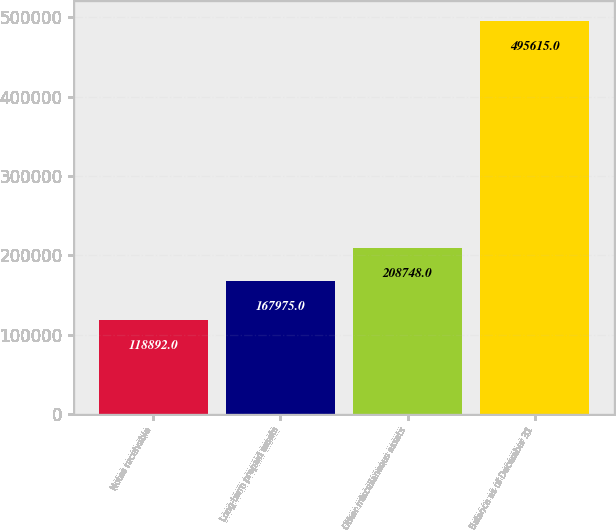<chart> <loc_0><loc_0><loc_500><loc_500><bar_chart><fcel>Notes receivable<fcel>Long-term prepaid assets<fcel>Other miscellaneous assets<fcel>Balance as of December 31<nl><fcel>118892<fcel>167975<fcel>208748<fcel>495615<nl></chart> 